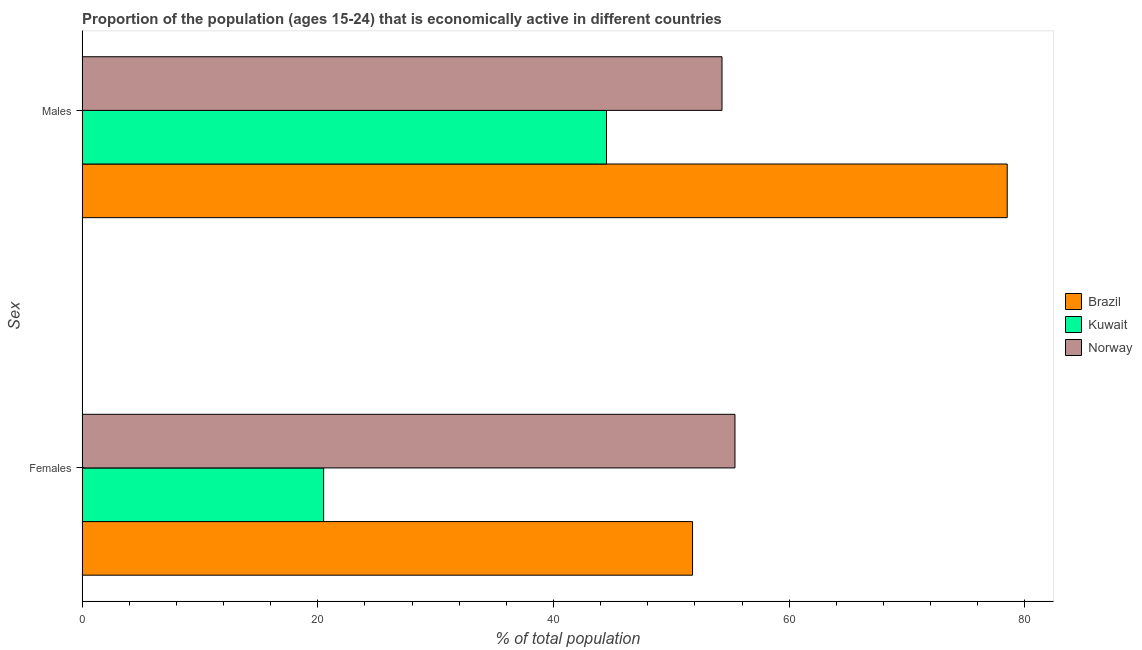How many different coloured bars are there?
Your answer should be very brief. 3. How many groups of bars are there?
Make the answer very short. 2. Are the number of bars per tick equal to the number of legend labels?
Offer a very short reply. Yes. How many bars are there on the 2nd tick from the top?
Give a very brief answer. 3. How many bars are there on the 2nd tick from the bottom?
Make the answer very short. 3. What is the label of the 1st group of bars from the top?
Your answer should be very brief. Males. What is the percentage of economically active female population in Brazil?
Make the answer very short. 51.8. Across all countries, what is the maximum percentage of economically active female population?
Your answer should be compact. 55.4. Across all countries, what is the minimum percentage of economically active female population?
Keep it short and to the point. 20.5. In which country was the percentage of economically active male population maximum?
Offer a very short reply. Brazil. In which country was the percentage of economically active male population minimum?
Offer a terse response. Kuwait. What is the total percentage of economically active female population in the graph?
Keep it short and to the point. 127.7. What is the difference between the percentage of economically active male population in Norway and that in Kuwait?
Your answer should be very brief. 9.8. What is the difference between the percentage of economically active female population in Kuwait and the percentage of economically active male population in Brazil?
Provide a short and direct response. -58. What is the average percentage of economically active female population per country?
Your answer should be very brief. 42.57. In how many countries, is the percentage of economically active female population greater than 16 %?
Your response must be concise. 3. What is the ratio of the percentage of economically active male population in Brazil to that in Norway?
Offer a very short reply. 1.45. Is the percentage of economically active female population in Kuwait less than that in Norway?
Provide a short and direct response. Yes. In how many countries, is the percentage of economically active male population greater than the average percentage of economically active male population taken over all countries?
Keep it short and to the point. 1. How many bars are there?
Provide a short and direct response. 6. How many countries are there in the graph?
Your response must be concise. 3. Does the graph contain any zero values?
Make the answer very short. No. Where does the legend appear in the graph?
Give a very brief answer. Center right. How are the legend labels stacked?
Offer a very short reply. Vertical. What is the title of the graph?
Provide a succinct answer. Proportion of the population (ages 15-24) that is economically active in different countries. Does "Middle East & North Africa (all income levels)" appear as one of the legend labels in the graph?
Your response must be concise. No. What is the label or title of the X-axis?
Your answer should be compact. % of total population. What is the label or title of the Y-axis?
Offer a terse response. Sex. What is the % of total population in Brazil in Females?
Provide a succinct answer. 51.8. What is the % of total population of Norway in Females?
Keep it short and to the point. 55.4. What is the % of total population of Brazil in Males?
Offer a terse response. 78.5. What is the % of total population in Kuwait in Males?
Make the answer very short. 44.5. What is the % of total population of Norway in Males?
Offer a very short reply. 54.3. Across all Sex, what is the maximum % of total population of Brazil?
Give a very brief answer. 78.5. Across all Sex, what is the maximum % of total population of Kuwait?
Keep it short and to the point. 44.5. Across all Sex, what is the maximum % of total population of Norway?
Provide a succinct answer. 55.4. Across all Sex, what is the minimum % of total population in Brazil?
Your answer should be very brief. 51.8. Across all Sex, what is the minimum % of total population in Norway?
Make the answer very short. 54.3. What is the total % of total population in Brazil in the graph?
Offer a very short reply. 130.3. What is the total % of total population in Kuwait in the graph?
Offer a terse response. 65. What is the total % of total population of Norway in the graph?
Ensure brevity in your answer.  109.7. What is the difference between the % of total population of Brazil in Females and that in Males?
Give a very brief answer. -26.7. What is the difference between the % of total population in Norway in Females and that in Males?
Your answer should be compact. 1.1. What is the difference between the % of total population in Brazil in Females and the % of total population in Kuwait in Males?
Your response must be concise. 7.3. What is the difference between the % of total population of Brazil in Females and the % of total population of Norway in Males?
Your answer should be compact. -2.5. What is the difference between the % of total population of Kuwait in Females and the % of total population of Norway in Males?
Give a very brief answer. -33.8. What is the average % of total population of Brazil per Sex?
Offer a terse response. 65.15. What is the average % of total population in Kuwait per Sex?
Keep it short and to the point. 32.5. What is the average % of total population in Norway per Sex?
Your answer should be compact. 54.85. What is the difference between the % of total population of Brazil and % of total population of Kuwait in Females?
Your response must be concise. 31.3. What is the difference between the % of total population in Kuwait and % of total population in Norway in Females?
Keep it short and to the point. -34.9. What is the difference between the % of total population in Brazil and % of total population in Norway in Males?
Give a very brief answer. 24.2. What is the difference between the % of total population of Kuwait and % of total population of Norway in Males?
Offer a very short reply. -9.8. What is the ratio of the % of total population in Brazil in Females to that in Males?
Your answer should be compact. 0.66. What is the ratio of the % of total population of Kuwait in Females to that in Males?
Your answer should be very brief. 0.46. What is the ratio of the % of total population of Norway in Females to that in Males?
Provide a short and direct response. 1.02. What is the difference between the highest and the second highest % of total population of Brazil?
Your answer should be compact. 26.7. What is the difference between the highest and the second highest % of total population in Kuwait?
Provide a succinct answer. 24. What is the difference between the highest and the second highest % of total population of Norway?
Your response must be concise. 1.1. What is the difference between the highest and the lowest % of total population in Brazil?
Provide a succinct answer. 26.7. 